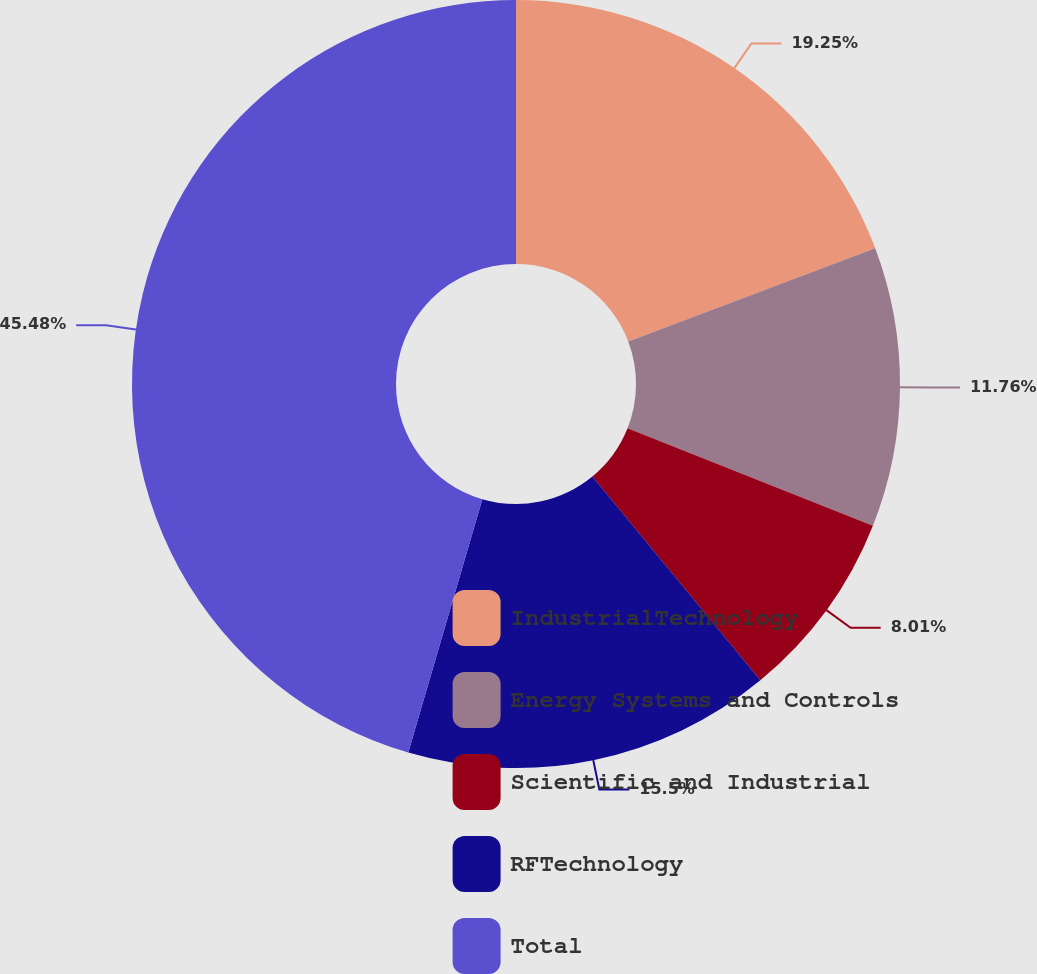<chart> <loc_0><loc_0><loc_500><loc_500><pie_chart><fcel>IndustrialTechnology<fcel>Energy Systems and Controls<fcel>Scientific and Industrial<fcel>RFTechnology<fcel>Total<nl><fcel>19.25%<fcel>11.76%<fcel>8.01%<fcel>15.5%<fcel>45.47%<nl></chart> 